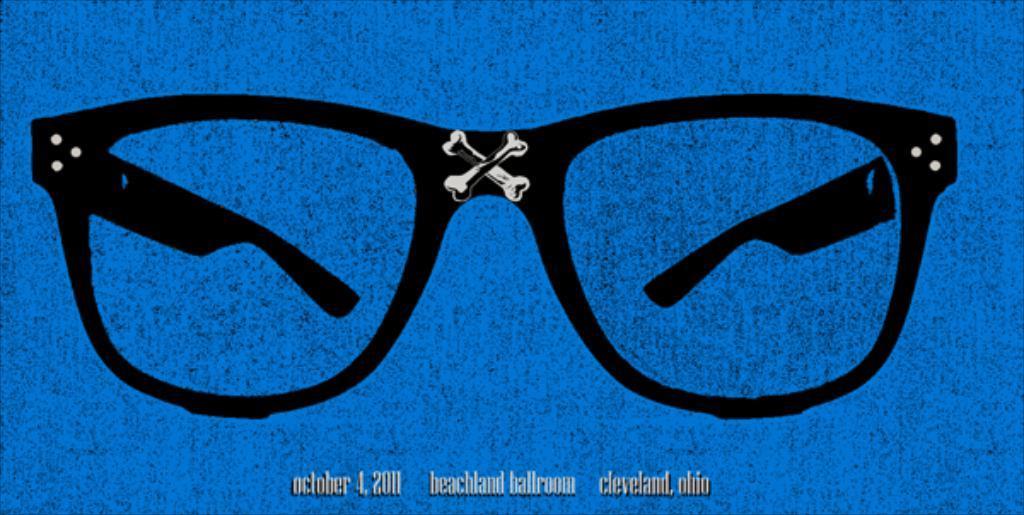Could you give a brief overview of what you see in this image? In this image I can see a black color specs and background is in blue color. 